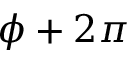<formula> <loc_0><loc_0><loc_500><loc_500>\phi + 2 \pi</formula> 